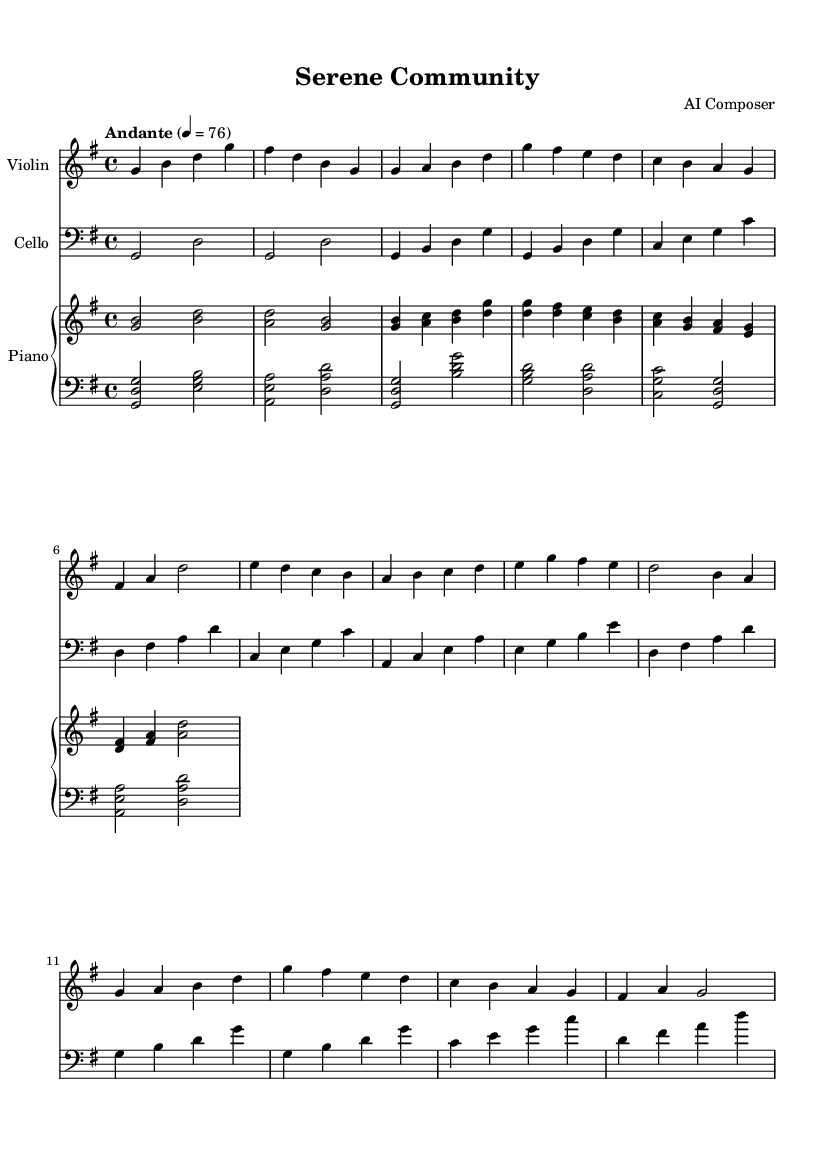What is the key signature of this music? The key signature shows one sharp, indicating that the music is in G major.
Answer: G major What is the time signature of the piece? The time signature is indicated as 4/4, meaning there are four beats in each measure, and the quarter note gets one beat.
Answer: 4/4 What is the tempo marking of the composition? The tempo marking reads "Andante" with a metronome marking of 76 beats per minute, suggesting a moderately slow pace.
Answer: Andante, 76 How many measures are in Section A of the piece? By counting the measures in Section A, which consists of specific phrases, we find that it has 4 measures.
Answer: 4 What is the range of the violin part in this piece? The violin part starts at the note G and goes up to high D, showing a range encompassing a full octave.
Answer: G to high D Which instrument has the simplest part in this score? The cello part is written with fewer notes and less complexity compared to the violin and piano parts, making it the simplest.
Answer: Cello What is the final note of Section B for the violin? By examining the end of Section B in the violin part, it concludes on the note B.
Answer: B 